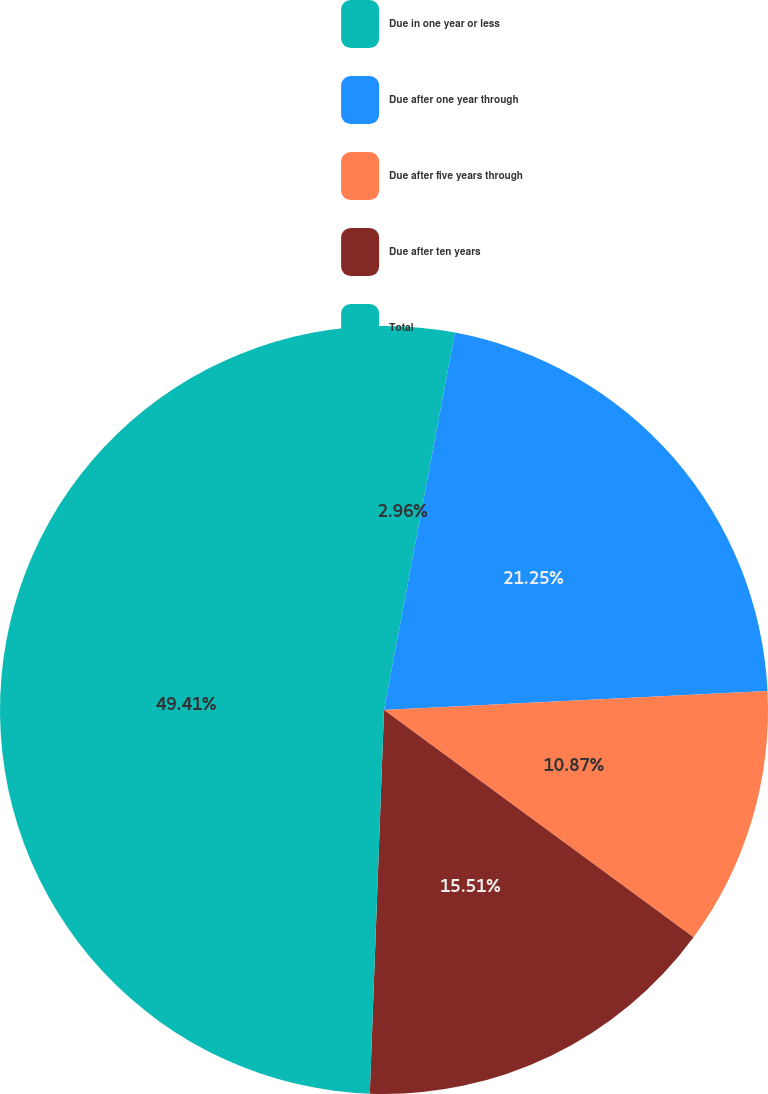Convert chart to OTSL. <chart><loc_0><loc_0><loc_500><loc_500><pie_chart><fcel>Due in one year or less<fcel>Due after one year through<fcel>Due after five years through<fcel>Due after ten years<fcel>Total<nl><fcel>2.96%<fcel>21.25%<fcel>10.87%<fcel>15.51%<fcel>49.41%<nl></chart> 